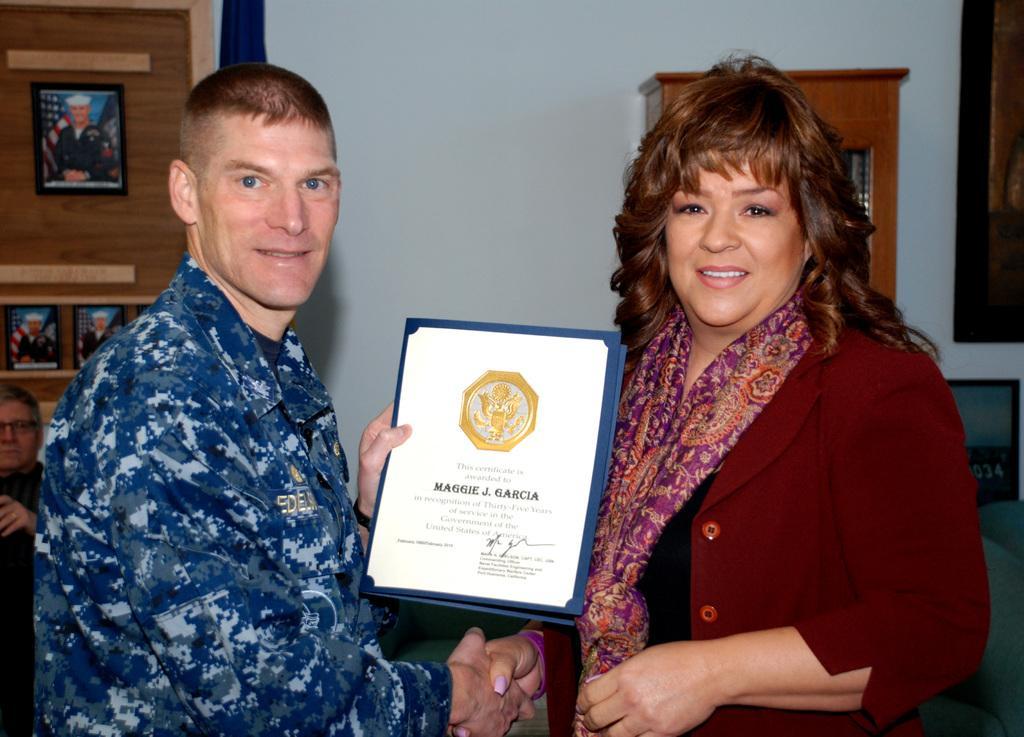Can you describe this image briefly? This image is taken indoors. In the background there is a wall with a window and a few picture frames and there is a cupboard. On the left side of the image a man is sitting on the chair and a man is standing on the floor and holding a certificate in his hands. On the right side of the image a woman is standing on the floor and she is with a smiling face. 